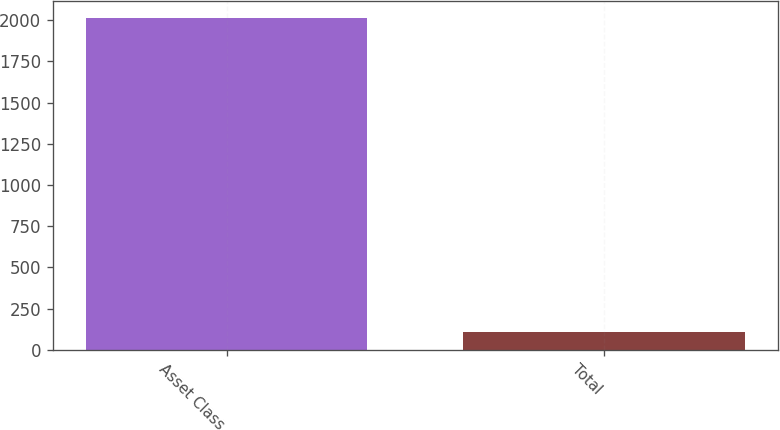Convert chart. <chart><loc_0><loc_0><loc_500><loc_500><bar_chart><fcel>Asset Class<fcel>Total<nl><fcel>2015<fcel>106<nl></chart> 